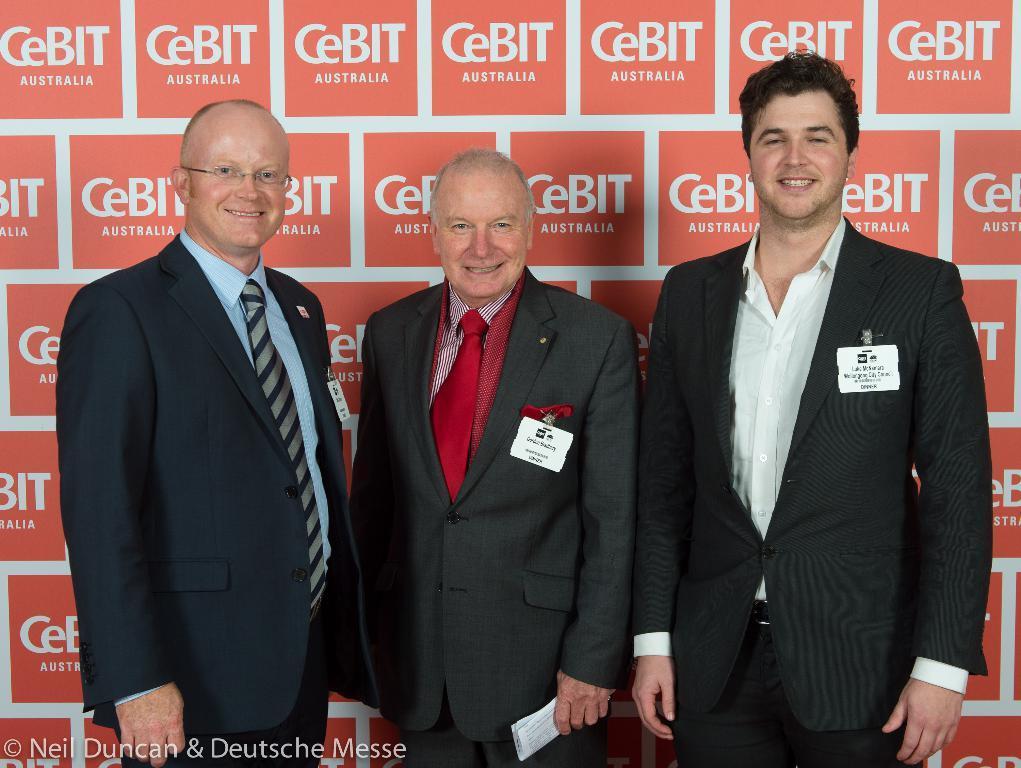Could you give a brief overview of what you see in this image? In this image there are three men standing together and smiling behind them there is a wall. 